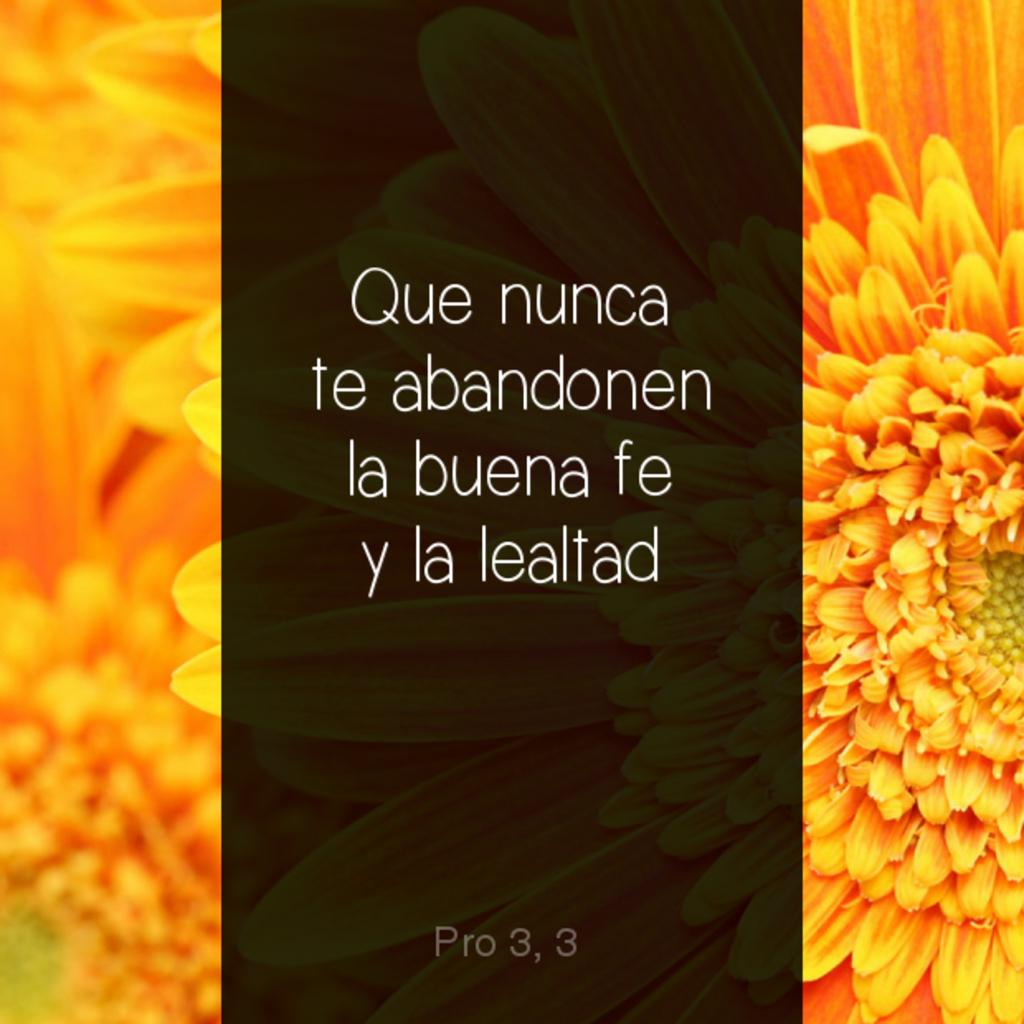What is the main subject in the middle of the image? There is a poster with text in the middle of the image. What else can be seen at the bottom of the image? There is text at the bottom of the image. What type of vegetation is present on the left side of the image? There are flowers on the left side of the image. Are there any flowers on the right side of the image? Yes, there are flowers on the right side of the image. What type of kettle is visible in the image? There is no kettle present in the image. What time is depicted on the poster in the image? The provided facts do not mention any time being depicted on the poster. 